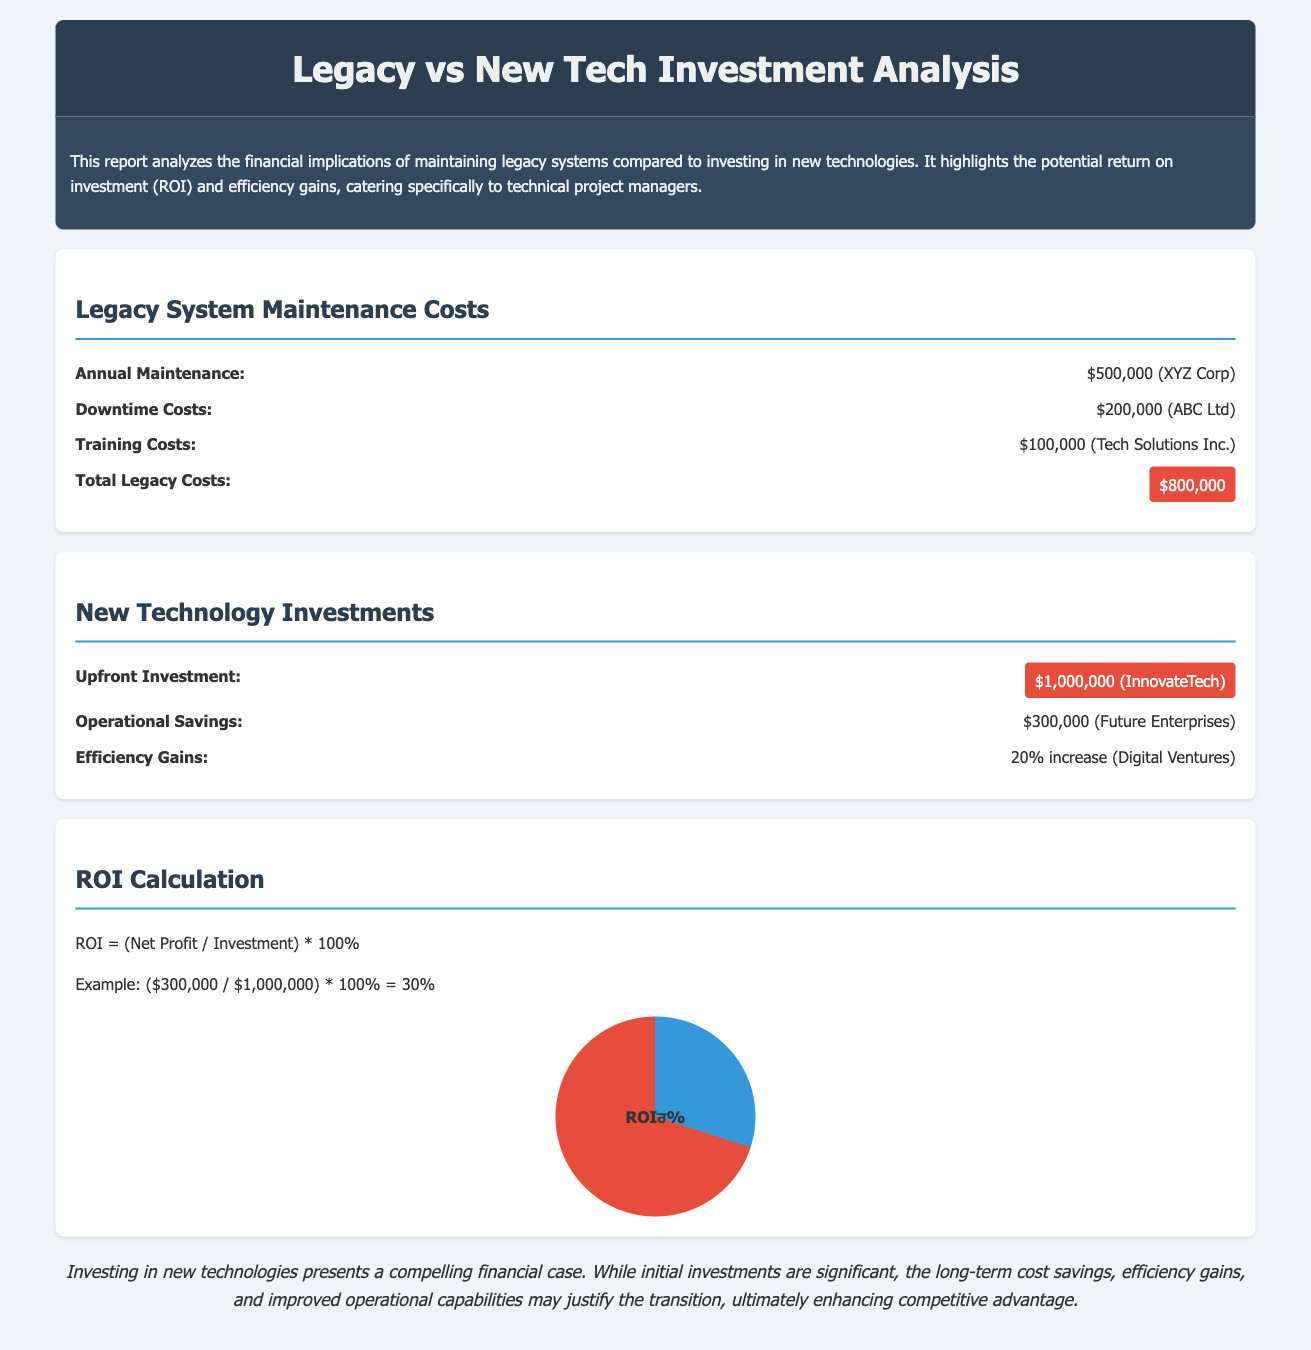What is the annual maintenance cost for legacy systems? The annual maintenance cost for legacy systems is stated as $500,000 for XYZ Corp.
Answer: $500,000 What is the total legacy cost? The total legacy cost is highlighted in the document as $800,000.
Answer: $800,000 What is the upfront investment for new technology? The upfront investment for new technology is highlighted as $1,000,000 for InnovateTech.
Answer: $1,000,000 What are the operational savings from new technology investments? The operational savings from new technology investments is $300,000 as stated in the document.
Answer: $300,000 What is the percentage increase in efficiency from new technology? The document states that there is a 20% increase in efficiency.
Answer: 20% What formula is used to calculate ROI? The formula provided in the report for calculating ROI is (Net Profit / Investment) * 100%.
Answer: (Net Profit / Investment) * 100% What is the calculated ROI from the example given in the report? The report provides an example that calculates ROI as 30%.
Answer: 30% What conclusion is drawn regarding the investment in new technologies? The conclusion emphasizes that investing in new technologies presents a compelling financial case.
Answer: A compelling financial case What does the document primarily analyze? The document primarily analyzes the financial implications of maintaining legacy systems versus investing in new technologies.
Answer: Financial implications 